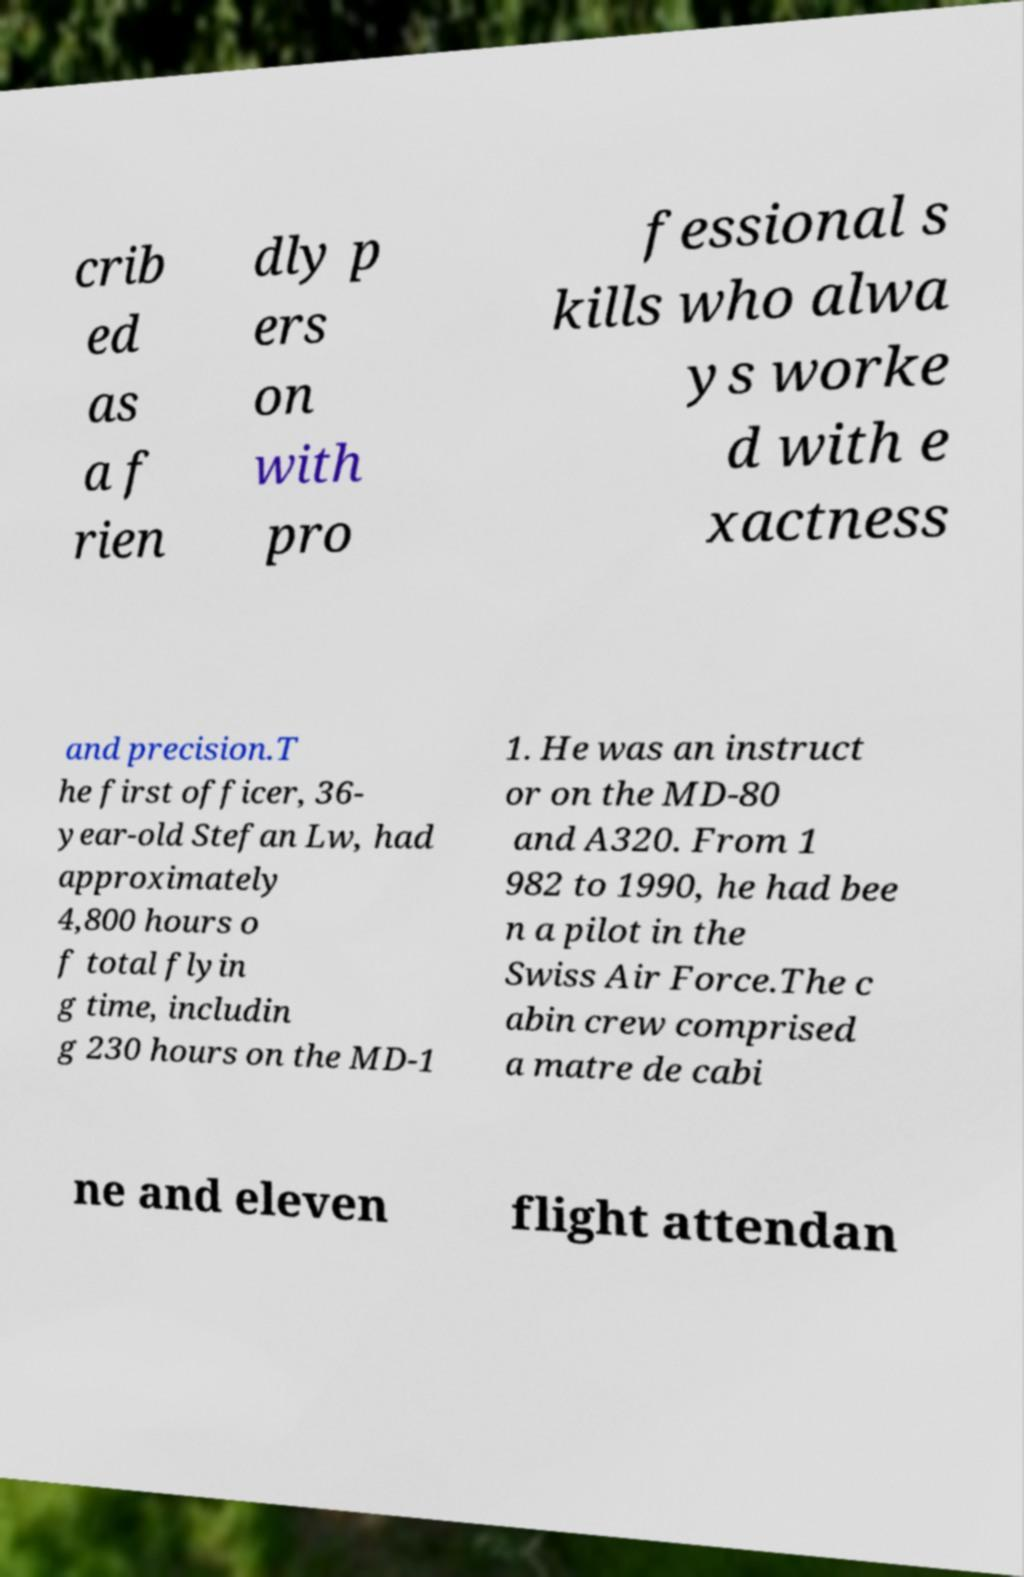What messages or text are displayed in this image? I need them in a readable, typed format. crib ed as a f rien dly p ers on with pro fessional s kills who alwa ys worke d with e xactness and precision.T he first officer, 36- year-old Stefan Lw, had approximately 4,800 hours o f total flyin g time, includin g 230 hours on the MD-1 1. He was an instruct or on the MD-80 and A320. From 1 982 to 1990, he had bee n a pilot in the Swiss Air Force.The c abin crew comprised a matre de cabi ne and eleven flight attendan 